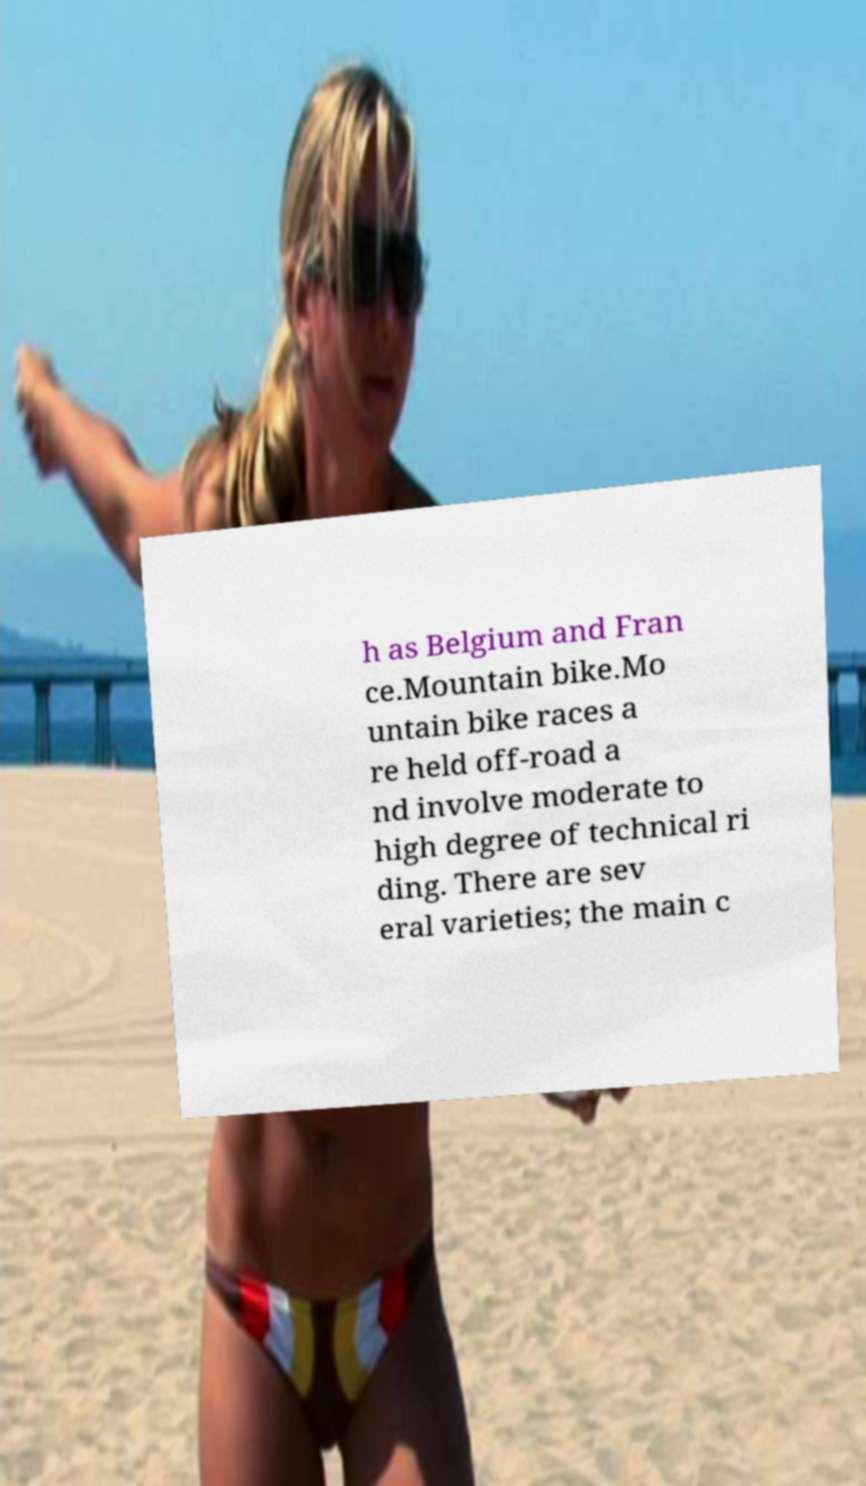There's text embedded in this image that I need extracted. Can you transcribe it verbatim? h as Belgium and Fran ce.Mountain bike.Mo untain bike races a re held off-road a nd involve moderate to high degree of technical ri ding. There are sev eral varieties; the main c 